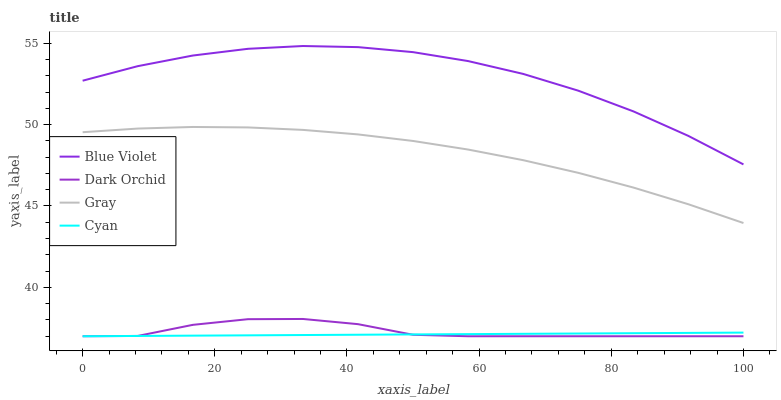Does Cyan have the minimum area under the curve?
Answer yes or no. Yes. Does Blue Violet have the maximum area under the curve?
Answer yes or no. Yes. Does Dark Orchid have the minimum area under the curve?
Answer yes or no. No. Does Dark Orchid have the maximum area under the curve?
Answer yes or no. No. Is Cyan the smoothest?
Answer yes or no. Yes. Is Dark Orchid the roughest?
Answer yes or no. Yes. Is Blue Violet the smoothest?
Answer yes or no. No. Is Blue Violet the roughest?
Answer yes or no. No. Does Dark Orchid have the lowest value?
Answer yes or no. Yes. Does Blue Violet have the lowest value?
Answer yes or no. No. Does Blue Violet have the highest value?
Answer yes or no. Yes. Does Dark Orchid have the highest value?
Answer yes or no. No. Is Dark Orchid less than Blue Violet?
Answer yes or no. Yes. Is Blue Violet greater than Cyan?
Answer yes or no. Yes. Does Cyan intersect Dark Orchid?
Answer yes or no. Yes. Is Cyan less than Dark Orchid?
Answer yes or no. No. Is Cyan greater than Dark Orchid?
Answer yes or no. No. Does Dark Orchid intersect Blue Violet?
Answer yes or no. No. 